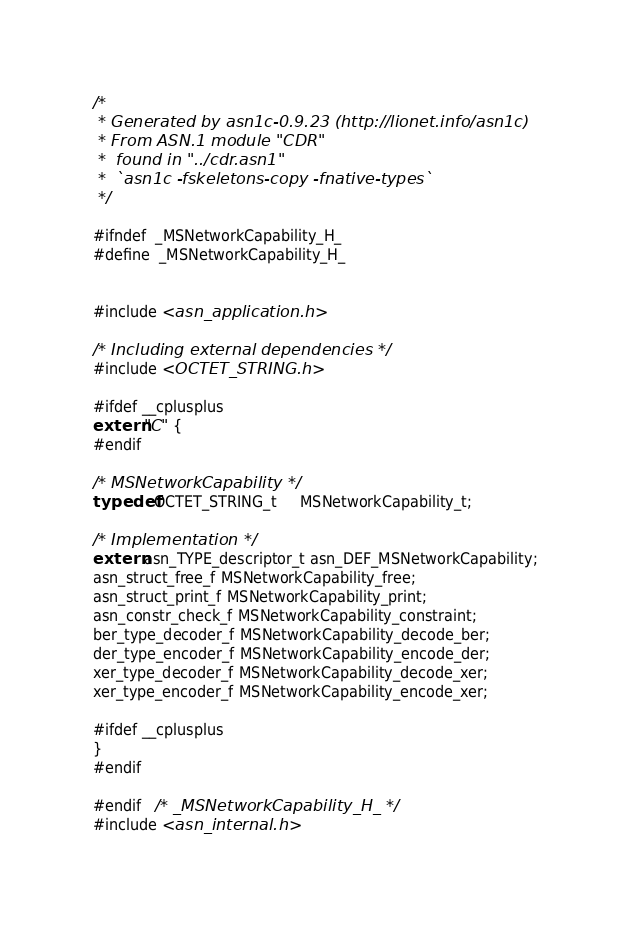Convert code to text. <code><loc_0><loc_0><loc_500><loc_500><_C_>/*
 * Generated by asn1c-0.9.23 (http://lionet.info/asn1c)
 * From ASN.1 module "CDR"
 * 	found in "../cdr.asn1"
 * 	`asn1c -fskeletons-copy -fnative-types`
 */

#ifndef	_MSNetworkCapability_H_
#define	_MSNetworkCapability_H_


#include <asn_application.h>

/* Including external dependencies */
#include <OCTET_STRING.h>

#ifdef __cplusplus
extern "C" {
#endif

/* MSNetworkCapability */
typedef OCTET_STRING_t	 MSNetworkCapability_t;

/* Implementation */
extern asn_TYPE_descriptor_t asn_DEF_MSNetworkCapability;
asn_struct_free_f MSNetworkCapability_free;
asn_struct_print_f MSNetworkCapability_print;
asn_constr_check_f MSNetworkCapability_constraint;
ber_type_decoder_f MSNetworkCapability_decode_ber;
der_type_encoder_f MSNetworkCapability_encode_der;
xer_type_decoder_f MSNetworkCapability_decode_xer;
xer_type_encoder_f MSNetworkCapability_encode_xer;

#ifdef __cplusplus
}
#endif

#endif	/* _MSNetworkCapability_H_ */
#include <asn_internal.h>
</code> 